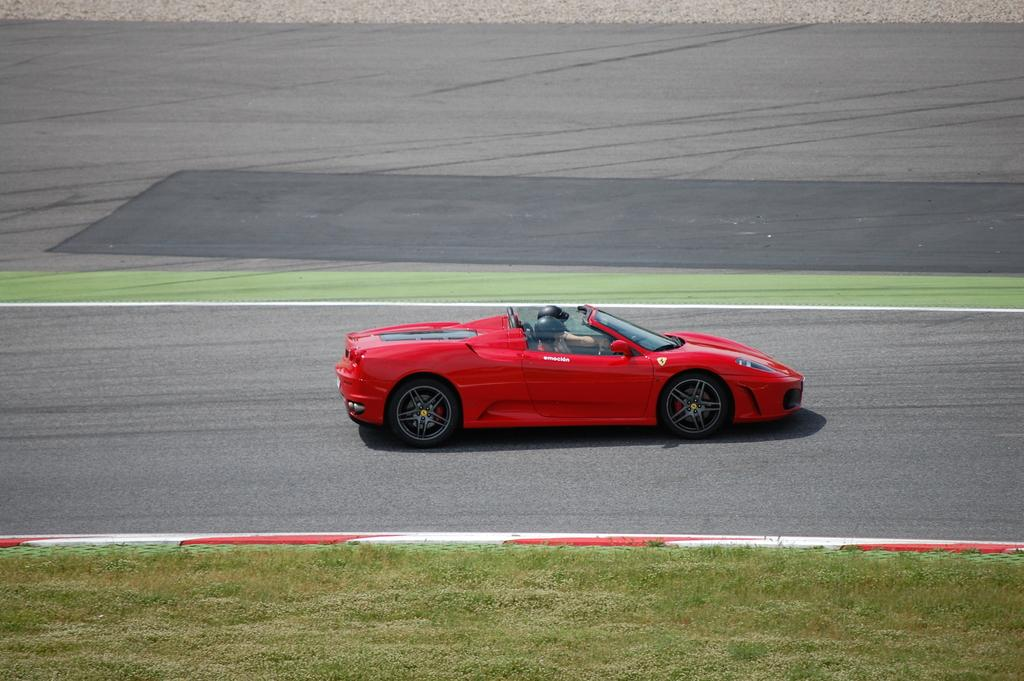What is happening in the image? There are people in the car, which is on the road. Can you describe the car? The car is red in color. What can be seen in the background of the image? There is grass visible in the background, along with other objects on the ground. What type of beetle can be seen crawling on the car's hood in the image? There is no beetle visible on the car's hood in the image. How many hands are visible in the image? There is no mention of hands in the provided facts, so it cannot be determined how many hands are visible in the image. 